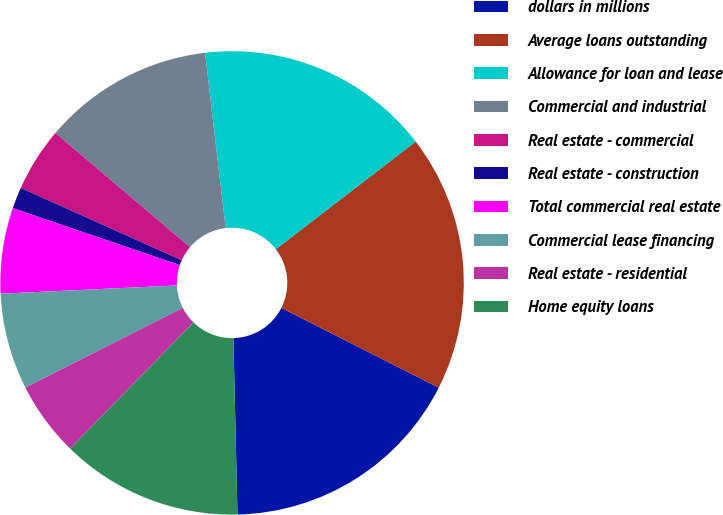Convert chart to OTSL. <chart><loc_0><loc_0><loc_500><loc_500><pie_chart><fcel>dollars in millions<fcel>Average loans outstanding<fcel>Allowance for loan and lease<fcel>Commercial and industrial<fcel>Real estate - commercial<fcel>Real estate - construction<fcel>Total commercial real estate<fcel>Commercial lease financing<fcel>Real estate - residential<fcel>Home equity loans<nl><fcel>17.16%<fcel>17.91%<fcel>16.42%<fcel>11.94%<fcel>4.48%<fcel>1.49%<fcel>5.97%<fcel>6.72%<fcel>5.22%<fcel>12.69%<nl></chart> 